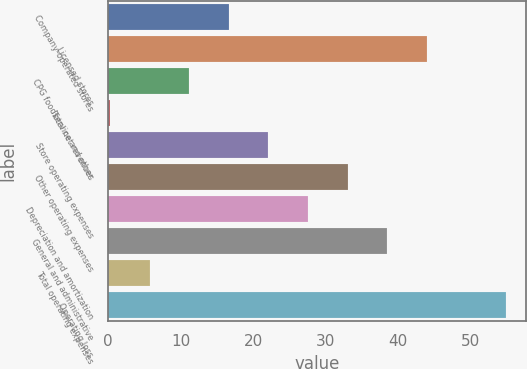Convert chart to OTSL. <chart><loc_0><loc_0><loc_500><loc_500><bar_chart><fcel>Company-operated stores<fcel>Licensed stores<fcel>CPG foodservice and other<fcel>Total net revenues<fcel>Store operating expenses<fcel>Other operating expenses<fcel>Depreciation and amortization<fcel>General and administrative<fcel>Total operating expenses<fcel>Operating loss<nl><fcel>16.65<fcel>43.9<fcel>11.2<fcel>0.3<fcel>22.1<fcel>33<fcel>27.55<fcel>38.45<fcel>5.75<fcel>54.8<nl></chart> 